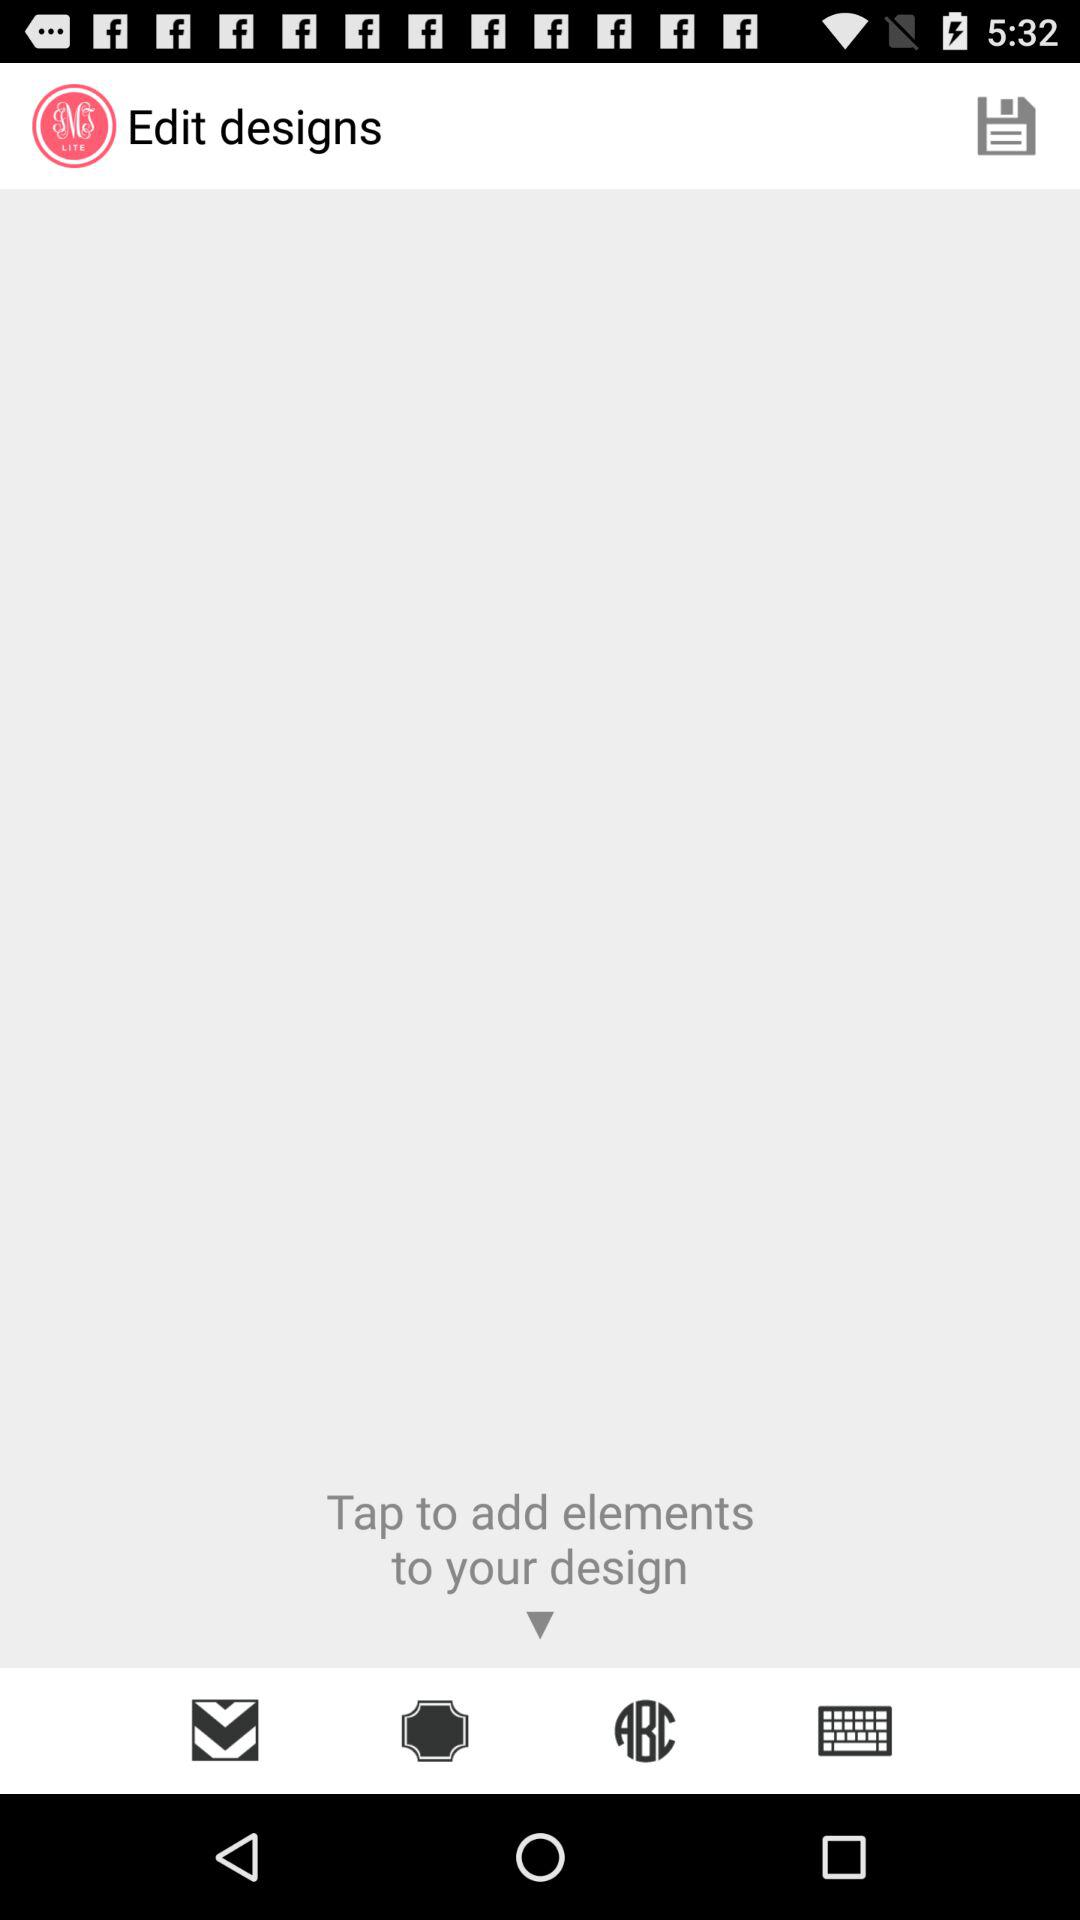What is the name of the application? The name of the application is "SMS LITE". 